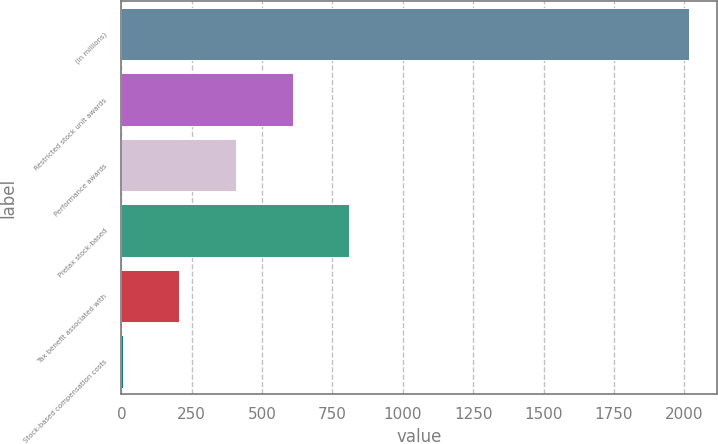<chart> <loc_0><loc_0><loc_500><loc_500><bar_chart><fcel>(in millions)<fcel>Restricted stock unit awards<fcel>Performance awards<fcel>Pretax stock-based<fcel>Tax benefit associated with<fcel>Stock-based compensation costs<nl><fcel>2017<fcel>607.9<fcel>406.6<fcel>809.2<fcel>205.3<fcel>4<nl></chart> 